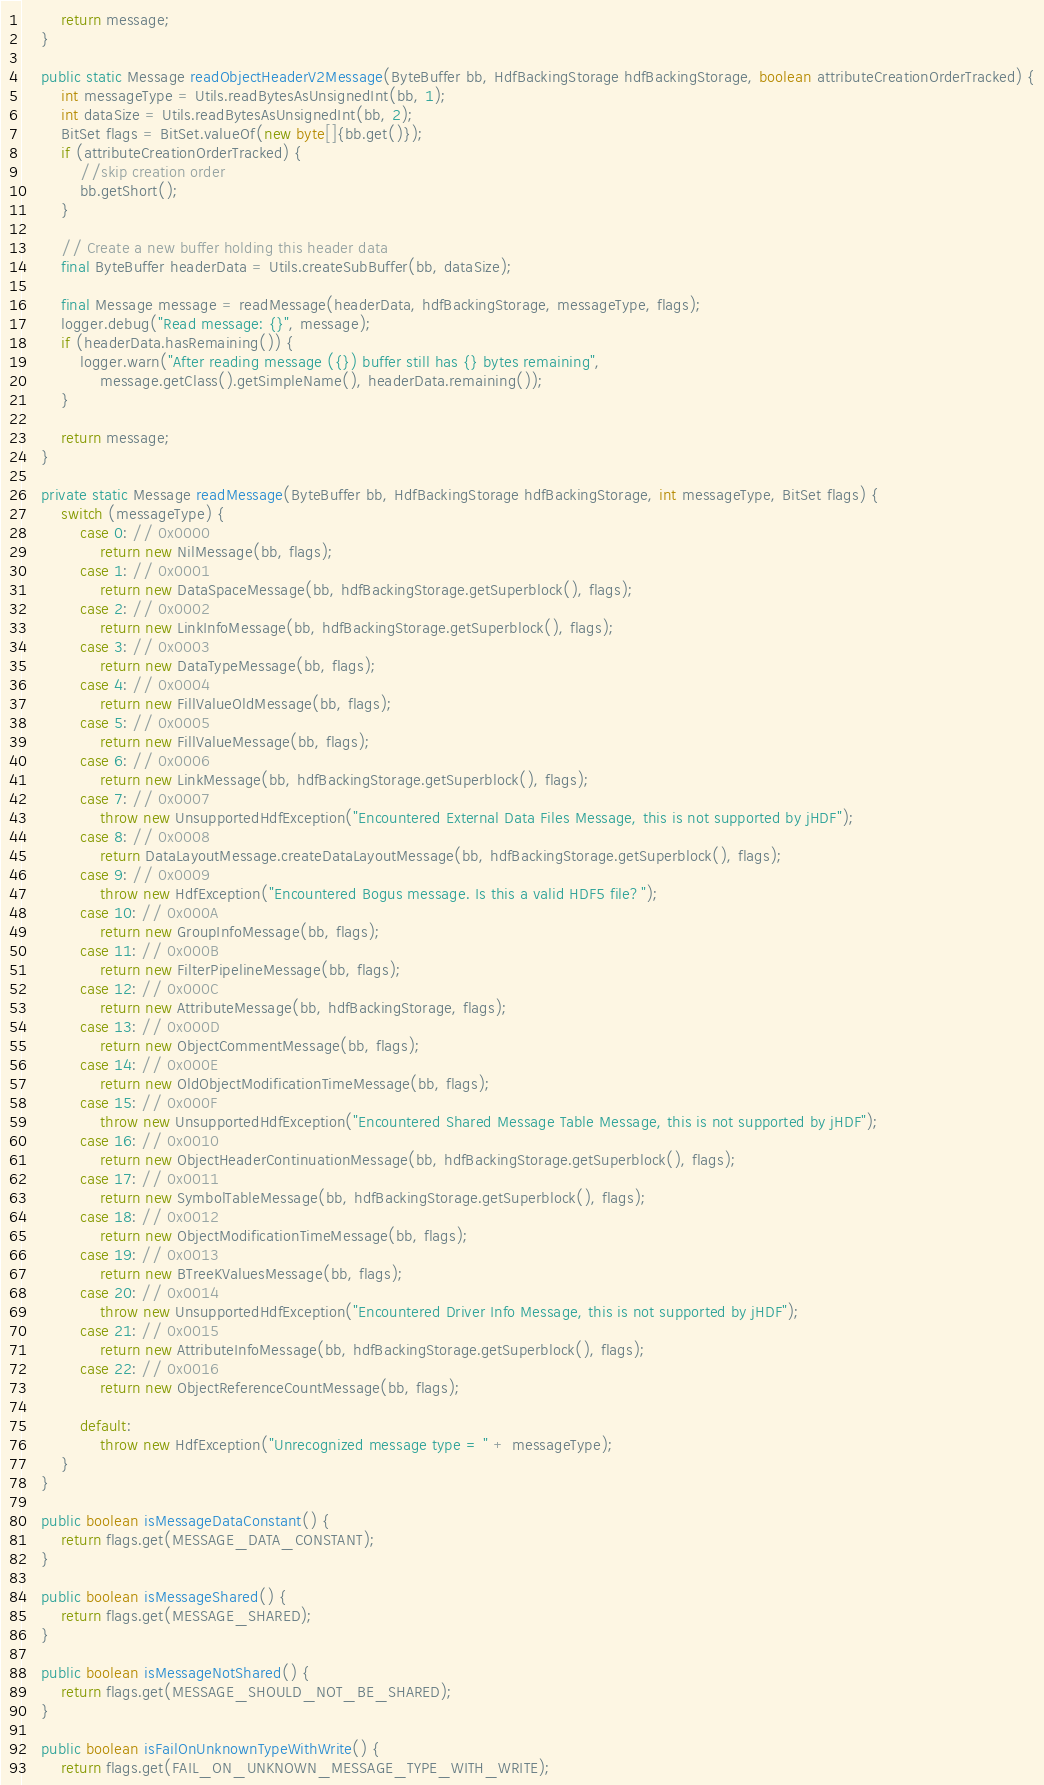Convert code to text. <code><loc_0><loc_0><loc_500><loc_500><_Java_>
		return message;
	}

	public static Message readObjectHeaderV2Message(ByteBuffer bb, HdfBackingStorage hdfBackingStorage, boolean attributeCreationOrderTracked) {
		int messageType = Utils.readBytesAsUnsignedInt(bb, 1);
		int dataSize = Utils.readBytesAsUnsignedInt(bb, 2);
		BitSet flags = BitSet.valueOf(new byte[]{bb.get()});
		if (attributeCreationOrderTracked) {
			//skip creation order
			bb.getShort();
		}

		// Create a new buffer holding this header data
		final ByteBuffer headerData = Utils.createSubBuffer(bb, dataSize);

		final Message message = readMessage(headerData, hdfBackingStorage, messageType, flags);
		logger.debug("Read message: {}", message);
		if (headerData.hasRemaining()) {
			logger.warn("After reading message ({}) buffer still has {} bytes remaining",
				message.getClass().getSimpleName(), headerData.remaining());
		}

		return message;
	}

	private static Message readMessage(ByteBuffer bb, HdfBackingStorage hdfBackingStorage, int messageType, BitSet flags) {
		switch (messageType) {
			case 0: // 0x0000
				return new NilMessage(bb, flags);
			case 1: // 0x0001
				return new DataSpaceMessage(bb, hdfBackingStorage.getSuperblock(), flags);
			case 2: // 0x0002
				return new LinkInfoMessage(bb, hdfBackingStorage.getSuperblock(), flags);
			case 3: // 0x0003
				return new DataTypeMessage(bb, flags);
			case 4: // 0x0004
				return new FillValueOldMessage(bb, flags);
			case 5: // 0x0005
				return new FillValueMessage(bb, flags);
			case 6: // 0x0006
				return new LinkMessage(bb, hdfBackingStorage.getSuperblock(), flags);
			case 7: // 0x0007
				throw new UnsupportedHdfException("Encountered External Data Files Message, this is not supported by jHDF");
			case 8: // 0x0008
				return DataLayoutMessage.createDataLayoutMessage(bb, hdfBackingStorage.getSuperblock(), flags);
			case 9: // 0x0009
				throw new HdfException("Encountered Bogus message. Is this a valid HDF5 file?");
			case 10: // 0x000A
				return new GroupInfoMessage(bb, flags);
			case 11: // 0x000B
				return new FilterPipelineMessage(bb, flags);
			case 12: // 0x000C
				return new AttributeMessage(bb, hdfBackingStorage, flags);
			case 13: // 0x000D
				return new ObjectCommentMessage(bb, flags);
			case 14: // 0x000E
				return new OldObjectModificationTimeMessage(bb, flags);
			case 15: // 0x000F
				throw new UnsupportedHdfException("Encountered Shared Message Table Message, this is not supported by jHDF");
			case 16: // 0x0010
				return new ObjectHeaderContinuationMessage(bb, hdfBackingStorage.getSuperblock(), flags);
			case 17: // 0x0011
				return new SymbolTableMessage(bb, hdfBackingStorage.getSuperblock(), flags);
			case 18: // 0x0012
				return new ObjectModificationTimeMessage(bb, flags);
			case 19: // 0x0013
				return new BTreeKValuesMessage(bb, flags);
			case 20: // 0x0014
				throw new UnsupportedHdfException("Encountered Driver Info Message, this is not supported by jHDF");
			case 21: // 0x0015
				return new AttributeInfoMessage(bb, hdfBackingStorage.getSuperblock(), flags);
			case 22: // 0x0016
				return new ObjectReferenceCountMessage(bb, flags);

			default:
				throw new HdfException("Unrecognized message type = " + messageType);
		}
	}

	public boolean isMessageDataConstant() {
		return flags.get(MESSAGE_DATA_CONSTANT);
	}

	public boolean isMessageShared() {
		return flags.get(MESSAGE_SHARED);
	}

	public boolean isMessageNotShared() {
		return flags.get(MESSAGE_SHOULD_NOT_BE_SHARED);
	}

	public boolean isFailOnUnknownTypeWithWrite() {
		return flags.get(FAIL_ON_UNKNOWN_MESSAGE_TYPE_WITH_WRITE);</code> 